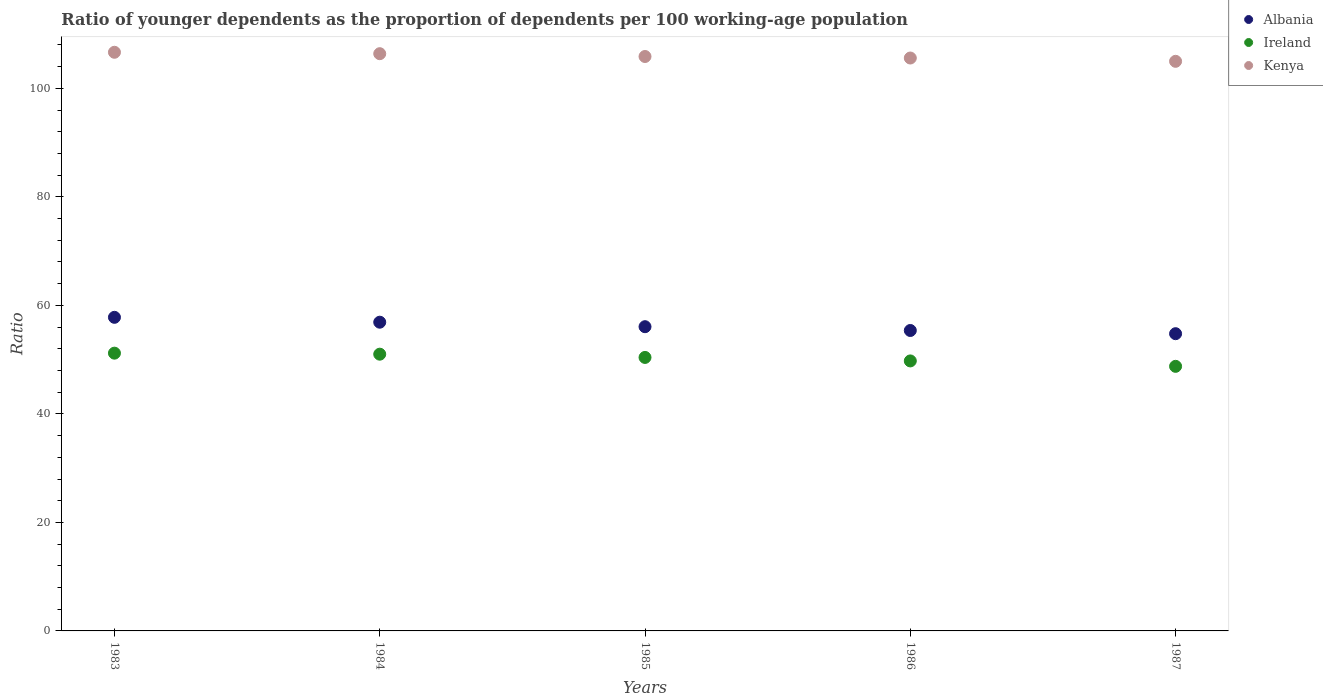How many different coloured dotlines are there?
Ensure brevity in your answer.  3. Is the number of dotlines equal to the number of legend labels?
Your answer should be very brief. Yes. What is the age dependency ratio(young) in Ireland in 1983?
Ensure brevity in your answer.  51.2. Across all years, what is the maximum age dependency ratio(young) in Albania?
Give a very brief answer. 57.8. Across all years, what is the minimum age dependency ratio(young) in Albania?
Keep it short and to the point. 54.78. In which year was the age dependency ratio(young) in Ireland minimum?
Make the answer very short. 1987. What is the total age dependency ratio(young) in Ireland in the graph?
Keep it short and to the point. 251.14. What is the difference between the age dependency ratio(young) in Ireland in 1984 and that in 1985?
Your response must be concise. 0.6. What is the difference between the age dependency ratio(young) in Albania in 1985 and the age dependency ratio(young) in Ireland in 1983?
Offer a terse response. 4.88. What is the average age dependency ratio(young) in Albania per year?
Provide a succinct answer. 56.19. In the year 1986, what is the difference between the age dependency ratio(young) in Kenya and age dependency ratio(young) in Albania?
Keep it short and to the point. 50.22. In how many years, is the age dependency ratio(young) in Kenya greater than 100?
Your response must be concise. 5. What is the ratio of the age dependency ratio(young) in Albania in 1986 to that in 1987?
Offer a very short reply. 1.01. What is the difference between the highest and the second highest age dependency ratio(young) in Albania?
Ensure brevity in your answer.  0.9. What is the difference between the highest and the lowest age dependency ratio(young) in Ireland?
Offer a very short reply. 2.43. In how many years, is the age dependency ratio(young) in Albania greater than the average age dependency ratio(young) in Albania taken over all years?
Make the answer very short. 2. Is the sum of the age dependency ratio(young) in Ireland in 1984 and 1987 greater than the maximum age dependency ratio(young) in Kenya across all years?
Your answer should be very brief. No. Is the age dependency ratio(young) in Albania strictly greater than the age dependency ratio(young) in Ireland over the years?
Provide a short and direct response. Yes. How many dotlines are there?
Make the answer very short. 3. Are the values on the major ticks of Y-axis written in scientific E-notation?
Offer a very short reply. No. Does the graph contain any zero values?
Give a very brief answer. No. Does the graph contain grids?
Make the answer very short. No. Where does the legend appear in the graph?
Keep it short and to the point. Top right. What is the title of the graph?
Offer a terse response. Ratio of younger dependents as the proportion of dependents per 100 working-age population. Does "Andorra" appear as one of the legend labels in the graph?
Provide a short and direct response. No. What is the label or title of the X-axis?
Provide a succinct answer. Years. What is the label or title of the Y-axis?
Your answer should be very brief. Ratio. What is the Ratio in Albania in 1983?
Offer a very short reply. 57.8. What is the Ratio in Ireland in 1983?
Make the answer very short. 51.2. What is the Ratio in Kenya in 1983?
Your response must be concise. 106.65. What is the Ratio of Albania in 1984?
Offer a very short reply. 56.9. What is the Ratio in Ireland in 1984?
Ensure brevity in your answer.  51.01. What is the Ratio in Kenya in 1984?
Your response must be concise. 106.39. What is the Ratio in Albania in 1985?
Give a very brief answer. 56.07. What is the Ratio of Ireland in 1985?
Keep it short and to the point. 50.41. What is the Ratio in Kenya in 1985?
Offer a very short reply. 105.87. What is the Ratio of Albania in 1986?
Keep it short and to the point. 55.37. What is the Ratio of Ireland in 1986?
Your answer should be compact. 49.77. What is the Ratio of Kenya in 1986?
Make the answer very short. 105.6. What is the Ratio in Albania in 1987?
Give a very brief answer. 54.78. What is the Ratio in Ireland in 1987?
Ensure brevity in your answer.  48.77. What is the Ratio in Kenya in 1987?
Make the answer very short. 104.99. Across all years, what is the maximum Ratio in Albania?
Your answer should be very brief. 57.8. Across all years, what is the maximum Ratio of Ireland?
Give a very brief answer. 51.2. Across all years, what is the maximum Ratio in Kenya?
Your answer should be very brief. 106.65. Across all years, what is the minimum Ratio of Albania?
Make the answer very short. 54.78. Across all years, what is the minimum Ratio of Ireland?
Ensure brevity in your answer.  48.77. Across all years, what is the minimum Ratio in Kenya?
Offer a terse response. 104.99. What is the total Ratio in Albania in the graph?
Your answer should be compact. 280.93. What is the total Ratio in Ireland in the graph?
Give a very brief answer. 251.14. What is the total Ratio of Kenya in the graph?
Offer a very short reply. 529.5. What is the difference between the Ratio in Albania in 1983 and that in 1984?
Offer a very short reply. 0.9. What is the difference between the Ratio in Ireland in 1983 and that in 1984?
Your answer should be very brief. 0.19. What is the difference between the Ratio of Kenya in 1983 and that in 1984?
Offer a very short reply. 0.26. What is the difference between the Ratio of Albania in 1983 and that in 1985?
Your response must be concise. 1.73. What is the difference between the Ratio of Ireland in 1983 and that in 1985?
Your response must be concise. 0.79. What is the difference between the Ratio of Kenya in 1983 and that in 1985?
Your answer should be compact. 0.78. What is the difference between the Ratio of Albania in 1983 and that in 1986?
Ensure brevity in your answer.  2.43. What is the difference between the Ratio in Ireland in 1983 and that in 1986?
Your response must be concise. 1.43. What is the difference between the Ratio in Kenya in 1983 and that in 1986?
Provide a short and direct response. 1.06. What is the difference between the Ratio in Albania in 1983 and that in 1987?
Your answer should be compact. 3.02. What is the difference between the Ratio of Ireland in 1983 and that in 1987?
Keep it short and to the point. 2.43. What is the difference between the Ratio in Kenya in 1983 and that in 1987?
Make the answer very short. 1.67. What is the difference between the Ratio of Albania in 1984 and that in 1985?
Give a very brief answer. 0.83. What is the difference between the Ratio in Ireland in 1984 and that in 1985?
Make the answer very short. 0.6. What is the difference between the Ratio of Kenya in 1984 and that in 1985?
Offer a terse response. 0.52. What is the difference between the Ratio of Albania in 1984 and that in 1986?
Provide a short and direct response. 1.53. What is the difference between the Ratio in Ireland in 1984 and that in 1986?
Ensure brevity in your answer.  1.24. What is the difference between the Ratio of Kenya in 1984 and that in 1986?
Your response must be concise. 0.8. What is the difference between the Ratio of Albania in 1984 and that in 1987?
Your answer should be very brief. 2.12. What is the difference between the Ratio in Ireland in 1984 and that in 1987?
Your answer should be very brief. 2.24. What is the difference between the Ratio of Kenya in 1984 and that in 1987?
Offer a terse response. 1.41. What is the difference between the Ratio in Albania in 1985 and that in 1986?
Ensure brevity in your answer.  0.7. What is the difference between the Ratio of Ireland in 1985 and that in 1986?
Your answer should be compact. 0.64. What is the difference between the Ratio of Kenya in 1985 and that in 1986?
Ensure brevity in your answer.  0.28. What is the difference between the Ratio in Albania in 1985 and that in 1987?
Make the answer very short. 1.29. What is the difference between the Ratio of Ireland in 1985 and that in 1987?
Provide a short and direct response. 1.64. What is the difference between the Ratio of Kenya in 1985 and that in 1987?
Give a very brief answer. 0.89. What is the difference between the Ratio in Albania in 1986 and that in 1987?
Ensure brevity in your answer.  0.59. What is the difference between the Ratio of Kenya in 1986 and that in 1987?
Keep it short and to the point. 0.61. What is the difference between the Ratio of Albania in 1983 and the Ratio of Ireland in 1984?
Keep it short and to the point. 6.79. What is the difference between the Ratio in Albania in 1983 and the Ratio in Kenya in 1984?
Your response must be concise. -48.59. What is the difference between the Ratio in Ireland in 1983 and the Ratio in Kenya in 1984?
Your answer should be very brief. -55.2. What is the difference between the Ratio in Albania in 1983 and the Ratio in Ireland in 1985?
Make the answer very short. 7.39. What is the difference between the Ratio in Albania in 1983 and the Ratio in Kenya in 1985?
Provide a short and direct response. -48.07. What is the difference between the Ratio in Ireland in 1983 and the Ratio in Kenya in 1985?
Ensure brevity in your answer.  -54.68. What is the difference between the Ratio in Albania in 1983 and the Ratio in Ireland in 1986?
Offer a very short reply. 8.04. What is the difference between the Ratio in Albania in 1983 and the Ratio in Kenya in 1986?
Provide a succinct answer. -47.79. What is the difference between the Ratio in Ireland in 1983 and the Ratio in Kenya in 1986?
Your answer should be very brief. -54.4. What is the difference between the Ratio in Albania in 1983 and the Ratio in Ireland in 1987?
Your answer should be compact. 9.03. What is the difference between the Ratio of Albania in 1983 and the Ratio of Kenya in 1987?
Make the answer very short. -47.19. What is the difference between the Ratio in Ireland in 1983 and the Ratio in Kenya in 1987?
Provide a succinct answer. -53.79. What is the difference between the Ratio in Albania in 1984 and the Ratio in Ireland in 1985?
Provide a succinct answer. 6.5. What is the difference between the Ratio in Albania in 1984 and the Ratio in Kenya in 1985?
Provide a succinct answer. -48.97. What is the difference between the Ratio of Ireland in 1984 and the Ratio of Kenya in 1985?
Ensure brevity in your answer.  -54.87. What is the difference between the Ratio of Albania in 1984 and the Ratio of Ireland in 1986?
Offer a very short reply. 7.14. What is the difference between the Ratio of Albania in 1984 and the Ratio of Kenya in 1986?
Offer a very short reply. -48.69. What is the difference between the Ratio of Ireland in 1984 and the Ratio of Kenya in 1986?
Your answer should be very brief. -54.59. What is the difference between the Ratio of Albania in 1984 and the Ratio of Ireland in 1987?
Ensure brevity in your answer.  8.13. What is the difference between the Ratio of Albania in 1984 and the Ratio of Kenya in 1987?
Make the answer very short. -48.08. What is the difference between the Ratio in Ireland in 1984 and the Ratio in Kenya in 1987?
Ensure brevity in your answer.  -53.98. What is the difference between the Ratio of Albania in 1985 and the Ratio of Ireland in 1986?
Offer a terse response. 6.31. What is the difference between the Ratio in Albania in 1985 and the Ratio in Kenya in 1986?
Your answer should be very brief. -49.52. What is the difference between the Ratio in Ireland in 1985 and the Ratio in Kenya in 1986?
Keep it short and to the point. -55.19. What is the difference between the Ratio of Albania in 1985 and the Ratio of Ireland in 1987?
Ensure brevity in your answer.  7.31. What is the difference between the Ratio of Albania in 1985 and the Ratio of Kenya in 1987?
Provide a succinct answer. -48.91. What is the difference between the Ratio in Ireland in 1985 and the Ratio in Kenya in 1987?
Your answer should be compact. -54.58. What is the difference between the Ratio in Albania in 1986 and the Ratio in Ireland in 1987?
Make the answer very short. 6.61. What is the difference between the Ratio of Albania in 1986 and the Ratio of Kenya in 1987?
Give a very brief answer. -49.61. What is the difference between the Ratio in Ireland in 1986 and the Ratio in Kenya in 1987?
Offer a terse response. -55.22. What is the average Ratio in Albania per year?
Give a very brief answer. 56.19. What is the average Ratio of Ireland per year?
Provide a succinct answer. 50.23. What is the average Ratio in Kenya per year?
Your answer should be compact. 105.9. In the year 1983, what is the difference between the Ratio of Albania and Ratio of Ireland?
Make the answer very short. 6.6. In the year 1983, what is the difference between the Ratio in Albania and Ratio in Kenya?
Provide a succinct answer. -48.85. In the year 1983, what is the difference between the Ratio of Ireland and Ratio of Kenya?
Ensure brevity in your answer.  -55.46. In the year 1984, what is the difference between the Ratio in Albania and Ratio in Ireland?
Offer a very short reply. 5.89. In the year 1984, what is the difference between the Ratio of Albania and Ratio of Kenya?
Ensure brevity in your answer.  -49.49. In the year 1984, what is the difference between the Ratio in Ireland and Ratio in Kenya?
Your response must be concise. -55.39. In the year 1985, what is the difference between the Ratio in Albania and Ratio in Ireland?
Provide a short and direct response. 5.67. In the year 1985, what is the difference between the Ratio of Albania and Ratio of Kenya?
Provide a succinct answer. -49.8. In the year 1985, what is the difference between the Ratio of Ireland and Ratio of Kenya?
Make the answer very short. -55.47. In the year 1986, what is the difference between the Ratio in Albania and Ratio in Ireland?
Offer a very short reply. 5.61. In the year 1986, what is the difference between the Ratio in Albania and Ratio in Kenya?
Your response must be concise. -50.22. In the year 1986, what is the difference between the Ratio of Ireland and Ratio of Kenya?
Offer a very short reply. -55.83. In the year 1987, what is the difference between the Ratio in Albania and Ratio in Ireland?
Offer a very short reply. 6.02. In the year 1987, what is the difference between the Ratio of Albania and Ratio of Kenya?
Provide a succinct answer. -50.2. In the year 1987, what is the difference between the Ratio of Ireland and Ratio of Kenya?
Offer a terse response. -56.22. What is the ratio of the Ratio of Albania in 1983 to that in 1984?
Offer a terse response. 1.02. What is the ratio of the Ratio in Ireland in 1983 to that in 1984?
Offer a very short reply. 1. What is the ratio of the Ratio of Kenya in 1983 to that in 1984?
Provide a short and direct response. 1. What is the ratio of the Ratio of Albania in 1983 to that in 1985?
Your response must be concise. 1.03. What is the ratio of the Ratio of Ireland in 1983 to that in 1985?
Your answer should be very brief. 1.02. What is the ratio of the Ratio in Kenya in 1983 to that in 1985?
Your answer should be very brief. 1.01. What is the ratio of the Ratio of Albania in 1983 to that in 1986?
Keep it short and to the point. 1.04. What is the ratio of the Ratio of Ireland in 1983 to that in 1986?
Offer a very short reply. 1.03. What is the ratio of the Ratio in Albania in 1983 to that in 1987?
Give a very brief answer. 1.06. What is the ratio of the Ratio of Ireland in 1983 to that in 1987?
Provide a succinct answer. 1.05. What is the ratio of the Ratio in Kenya in 1983 to that in 1987?
Offer a terse response. 1.02. What is the ratio of the Ratio of Albania in 1984 to that in 1985?
Offer a terse response. 1.01. What is the ratio of the Ratio in Ireland in 1984 to that in 1985?
Offer a terse response. 1.01. What is the ratio of the Ratio of Albania in 1984 to that in 1986?
Your answer should be compact. 1.03. What is the ratio of the Ratio in Kenya in 1984 to that in 1986?
Offer a very short reply. 1.01. What is the ratio of the Ratio in Albania in 1984 to that in 1987?
Offer a very short reply. 1.04. What is the ratio of the Ratio of Ireland in 1984 to that in 1987?
Provide a succinct answer. 1.05. What is the ratio of the Ratio in Kenya in 1984 to that in 1987?
Provide a short and direct response. 1.01. What is the ratio of the Ratio in Albania in 1985 to that in 1986?
Ensure brevity in your answer.  1.01. What is the ratio of the Ratio of Ireland in 1985 to that in 1986?
Ensure brevity in your answer.  1.01. What is the ratio of the Ratio of Albania in 1985 to that in 1987?
Ensure brevity in your answer.  1.02. What is the ratio of the Ratio in Ireland in 1985 to that in 1987?
Provide a succinct answer. 1.03. What is the ratio of the Ratio of Kenya in 1985 to that in 1987?
Your answer should be very brief. 1.01. What is the ratio of the Ratio of Albania in 1986 to that in 1987?
Ensure brevity in your answer.  1.01. What is the ratio of the Ratio in Ireland in 1986 to that in 1987?
Offer a very short reply. 1.02. What is the ratio of the Ratio in Kenya in 1986 to that in 1987?
Keep it short and to the point. 1.01. What is the difference between the highest and the second highest Ratio of Albania?
Provide a succinct answer. 0.9. What is the difference between the highest and the second highest Ratio of Ireland?
Ensure brevity in your answer.  0.19. What is the difference between the highest and the second highest Ratio of Kenya?
Provide a short and direct response. 0.26. What is the difference between the highest and the lowest Ratio of Albania?
Your answer should be very brief. 3.02. What is the difference between the highest and the lowest Ratio of Ireland?
Your answer should be compact. 2.43. What is the difference between the highest and the lowest Ratio in Kenya?
Your response must be concise. 1.67. 